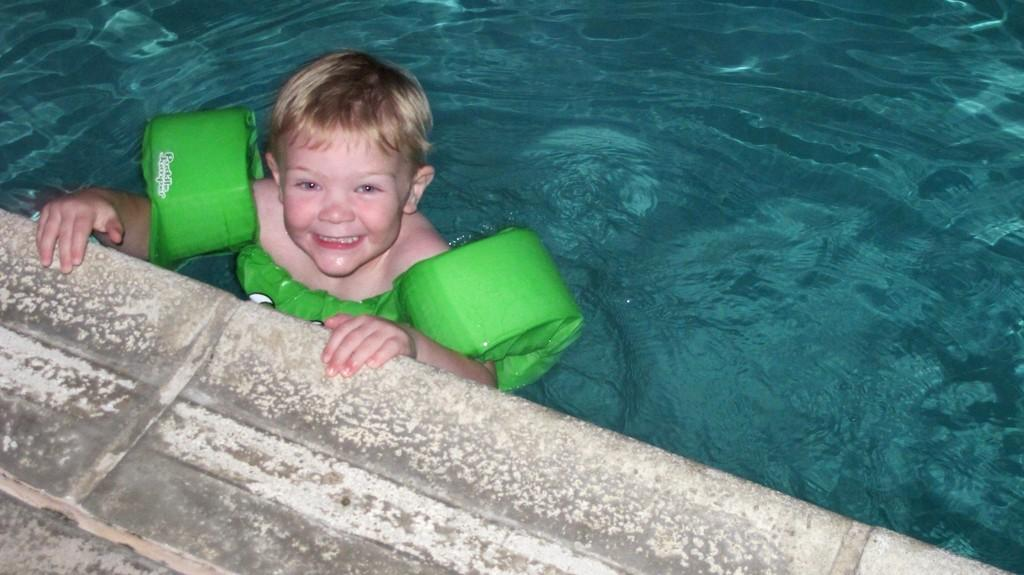Who is present in the image? There is a boy in the image. What is the boy doing in the image? The boy is smiling in the image. What is the boy wearing in the image? The boy is wearing a green life jacket in the image. Where is the boy standing in the image? The boy is standing in the water in the image. What type of water is the boy standing in? The water appears to be in a pool in the image. What can be seen in the background of the image? There is a wall visible in the image. What type of sock is the boy wearing on his desk in the image? There is no sock or desk present in the image; the boy is wearing a green life jacket and standing in water. 